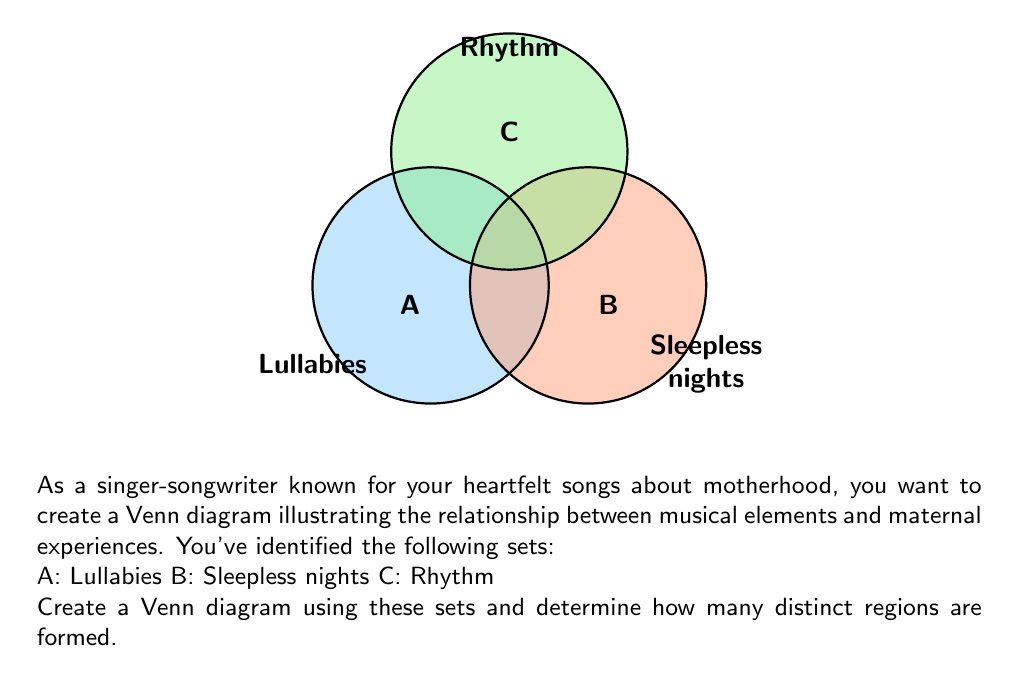Help me with this question. To determine the number of distinct regions in a Venn diagram with three sets, we can follow these steps:

1) First, recall that the maximum number of regions created by $n$ sets is given by the formula:

   $$2^n$$

2) In this case, we have 3 sets, so the maximum number of regions is:

   $$2^3 = 8$$

3) Let's break down these 8 regions:

   a) The region outside all circles (1 region)
   b) Regions unique to each set (3 regions)
   c) Regions where two sets overlap (3 regions)
   d) The region where all three sets overlap (1 region)

4) In our Venn diagram:
   - A represents Lullabies
   - B represents Sleepless nights
   - C represents Rhythm

5) Each of these regions represents a unique combination of musical elements and maternal experiences. For example:
   - The overlap of A and C could represent the rhythmic patterns in lullabies
   - The overlap of B and C might represent the rhythmic patterns of a baby's cries during sleepless nights
   - The central region where all sets overlap could represent rhythmic lullabies sung during sleepless nights

6) Count the distinct regions in the diagram. You should find that all 8 possible regions are present and distinct.

Therefore, the Venn diagram forms 8 distinct regions.
Answer: 8 regions 